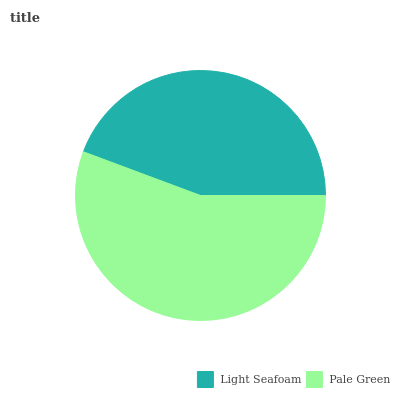Is Light Seafoam the minimum?
Answer yes or no. Yes. Is Pale Green the maximum?
Answer yes or no. Yes. Is Pale Green the minimum?
Answer yes or no. No. Is Pale Green greater than Light Seafoam?
Answer yes or no. Yes. Is Light Seafoam less than Pale Green?
Answer yes or no. Yes. Is Light Seafoam greater than Pale Green?
Answer yes or no. No. Is Pale Green less than Light Seafoam?
Answer yes or no. No. Is Pale Green the high median?
Answer yes or no. Yes. Is Light Seafoam the low median?
Answer yes or no. Yes. Is Light Seafoam the high median?
Answer yes or no. No. Is Pale Green the low median?
Answer yes or no. No. 